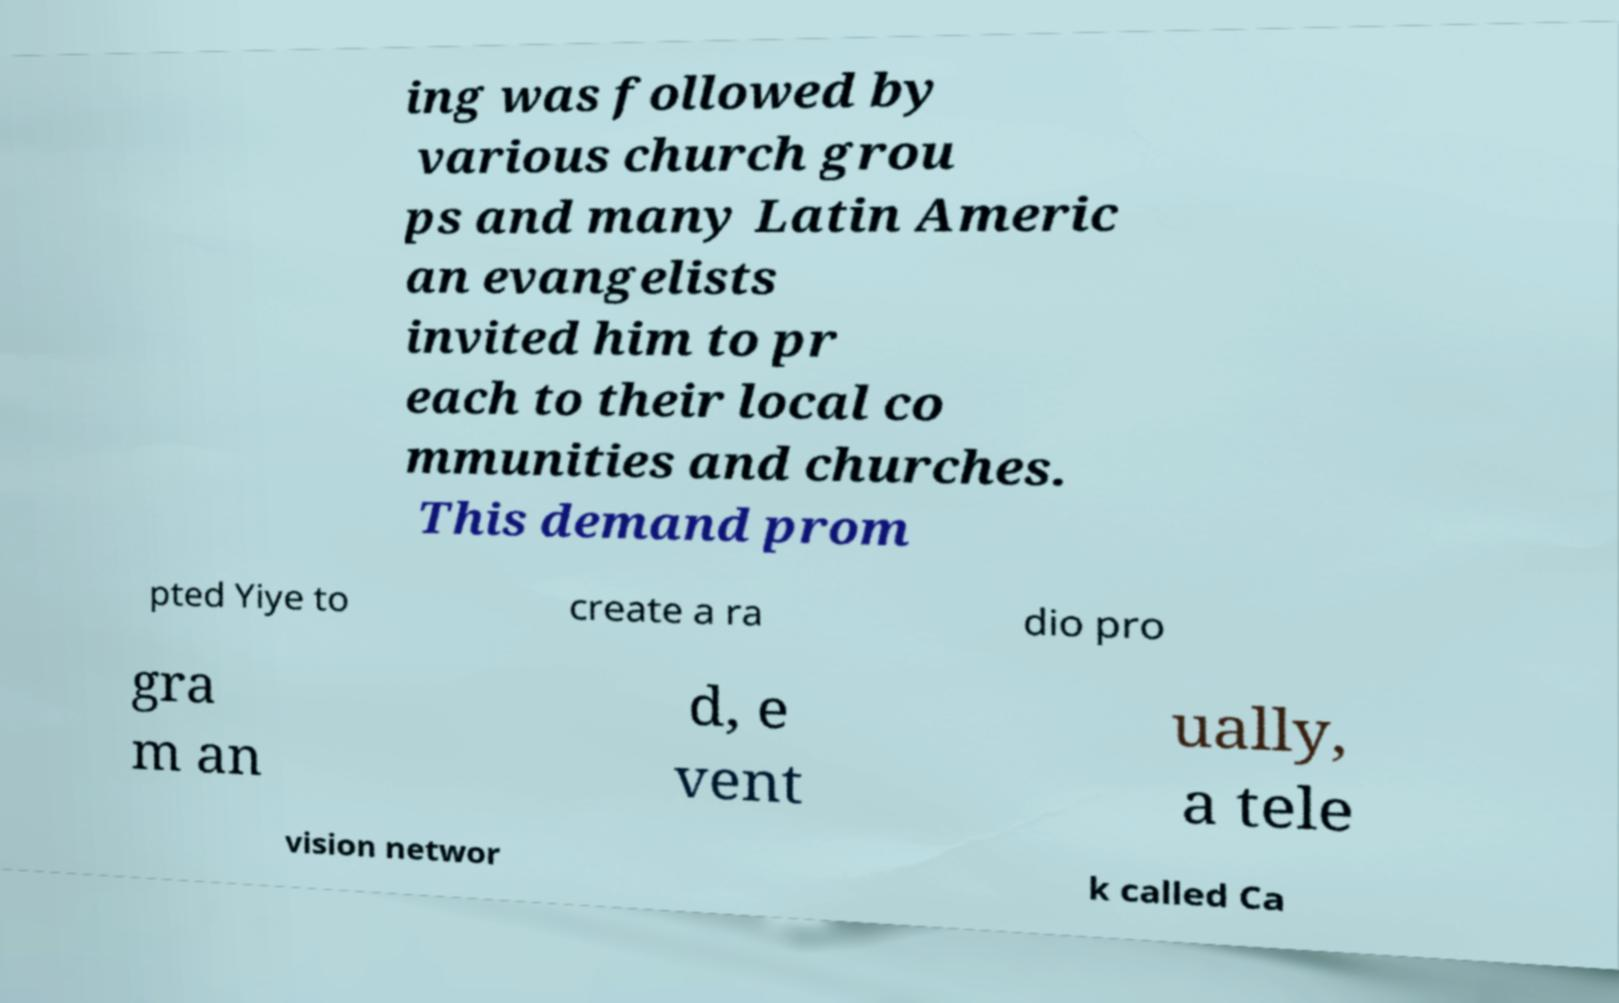There's text embedded in this image that I need extracted. Can you transcribe it verbatim? ing was followed by various church grou ps and many Latin Americ an evangelists invited him to pr each to their local co mmunities and churches. This demand prom pted Yiye to create a ra dio pro gra m an d, e vent ually, a tele vision networ k called Ca 